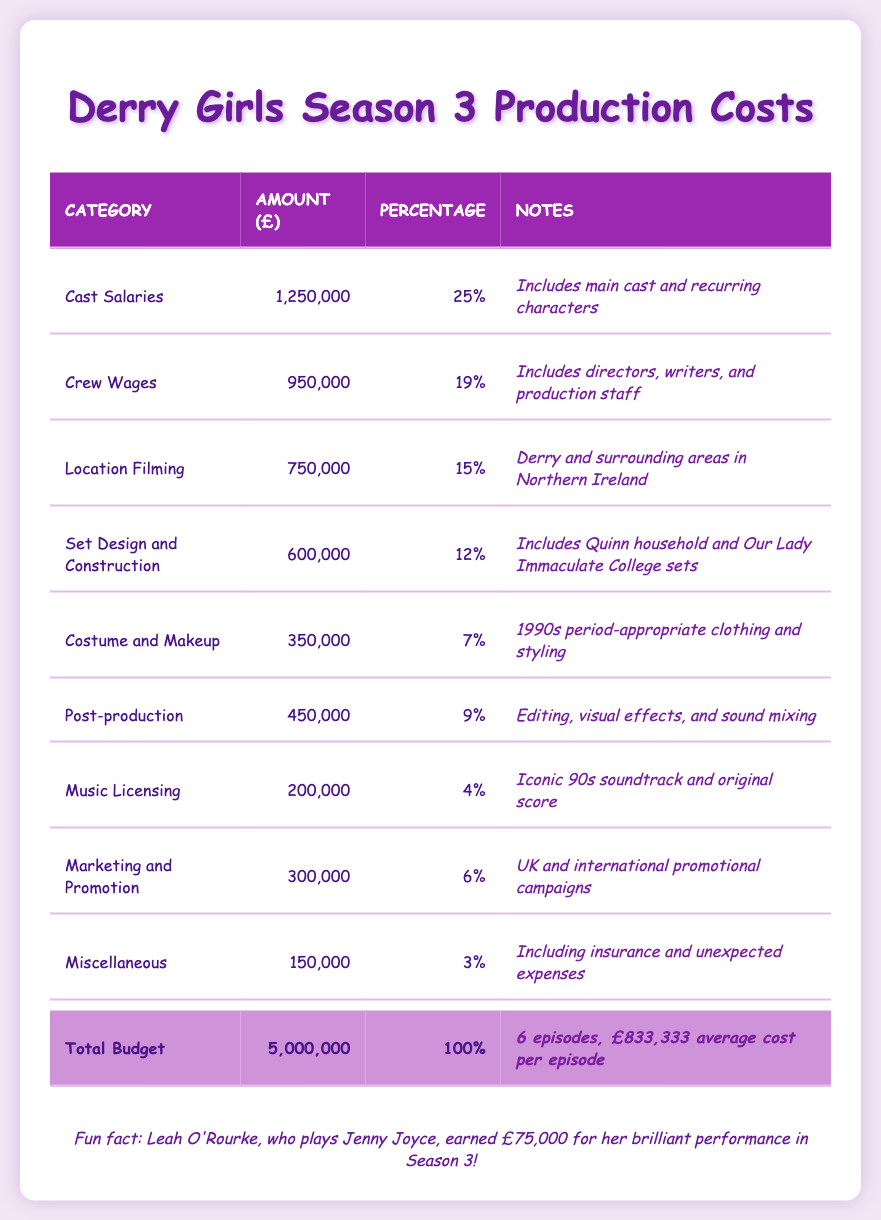What is the total budget for Season 3 of Derry Girls? The total budget is listed in the "Total Budget" row of the table, which shows £5,000,000.
Answer: £5,000,000 How much was spent on Cast Salaries? The "Cast Salaries" row indicates an amount of £1,250,000.
Answer: £1,250,000 What percentage of the total budget was allocated to Marketing and Promotion? The "Marketing and Promotion" category lists a percentage of 6%.
Answer: 6% What is the average cost per episode of Derry Girls Season 3? The average cost per episode is mentioned in the "Total Budget" row as £833,333.
Answer: £833,333 Is the amount spent on Costume and Makeup more than the amount spent on Music Licensing? The table shows that Costume and Makeup amounts to £350,000 and Music Licensing is £200,000. Since £350,000 is greater than £200,000, the answer is yes.
Answer: Yes If you combine the costs for Set Design and Construction and Location Filming, what would be the total? Set Design and Construction costs £600,000 and Location Filming costs £750,000. Adding these amounts gives £600,000 + £750,000 = £1,350,000.
Answer: £1,350,000 Did Channel 4 contribute more than Netflix for the production costs? Channel 4's contribution is £3,500,000 and Netflix's is £1,500,000. Since £3,500,000 is greater than £1,500,000, the answer is yes.
Answer: Yes What is the difference between the amounts spent on Crew Wages and Post-production? Crew Wages are £950,000 and Post-production is £450,000. The difference is £950,000 - £450,000 = £500,000.
Answer: £500,000 How much did Leah O'Rourke earn for her role in Season 3? The table states that Leah O'Rourke earned £75,000.
Answer: £75,000 What portion of the total budget is spent on Miscellaneous expenses? The "Miscellaneous" category shows an amount of £150,000. To find the portion, divide £150,000 by the total budget of £5,000,000, which equals 3%.
Answer: 3% 